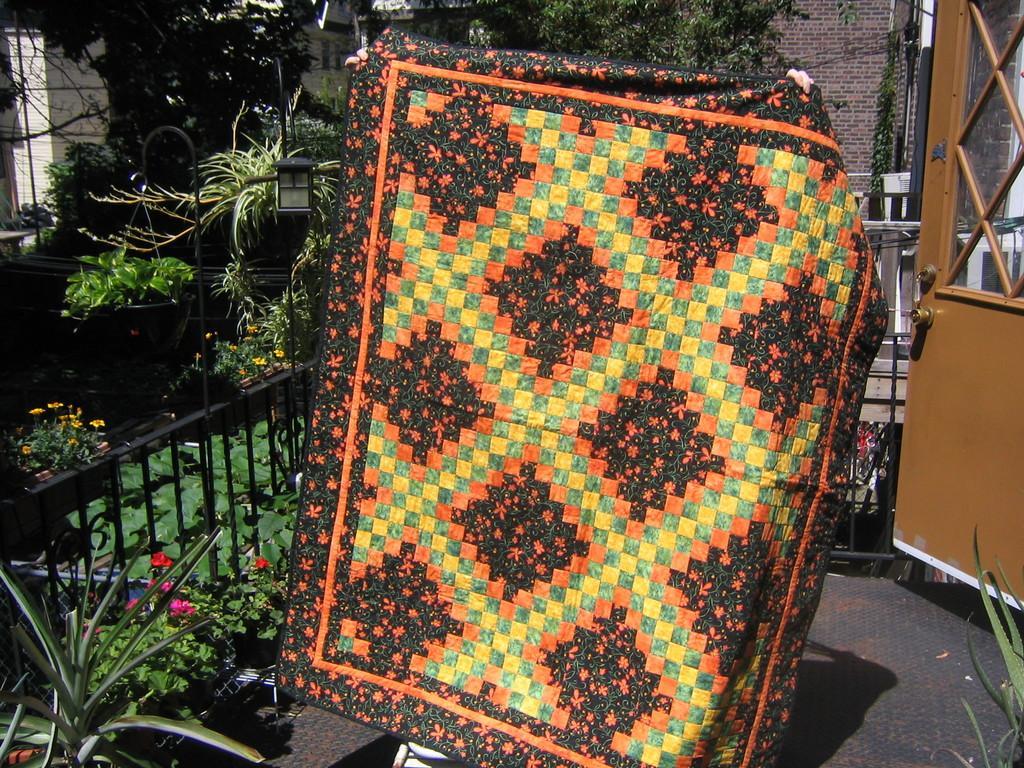Could you give a brief overview of what you see in this image? In the image we can see human hands, holding a carpet. Here we can see the fence, door, flower plants, grass and trees. Here we can see the brick wall and the floor. 